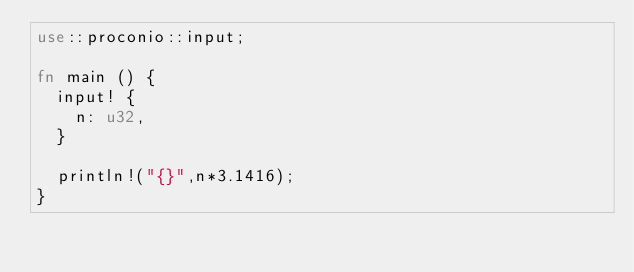Convert code to text. <code><loc_0><loc_0><loc_500><loc_500><_Rust_>use::proconio::input;

fn main () {
  input! {
    n: u32,
  }
  
  println!("{}",n*3.1416);
}</code> 